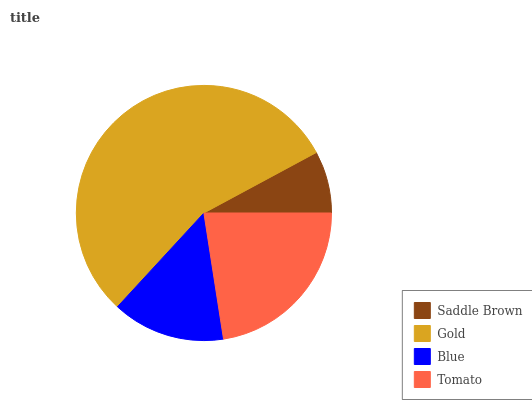Is Saddle Brown the minimum?
Answer yes or no. Yes. Is Gold the maximum?
Answer yes or no. Yes. Is Blue the minimum?
Answer yes or no. No. Is Blue the maximum?
Answer yes or no. No. Is Gold greater than Blue?
Answer yes or no. Yes. Is Blue less than Gold?
Answer yes or no. Yes. Is Blue greater than Gold?
Answer yes or no. No. Is Gold less than Blue?
Answer yes or no. No. Is Tomato the high median?
Answer yes or no. Yes. Is Blue the low median?
Answer yes or no. Yes. Is Saddle Brown the high median?
Answer yes or no. No. Is Gold the low median?
Answer yes or no. No. 